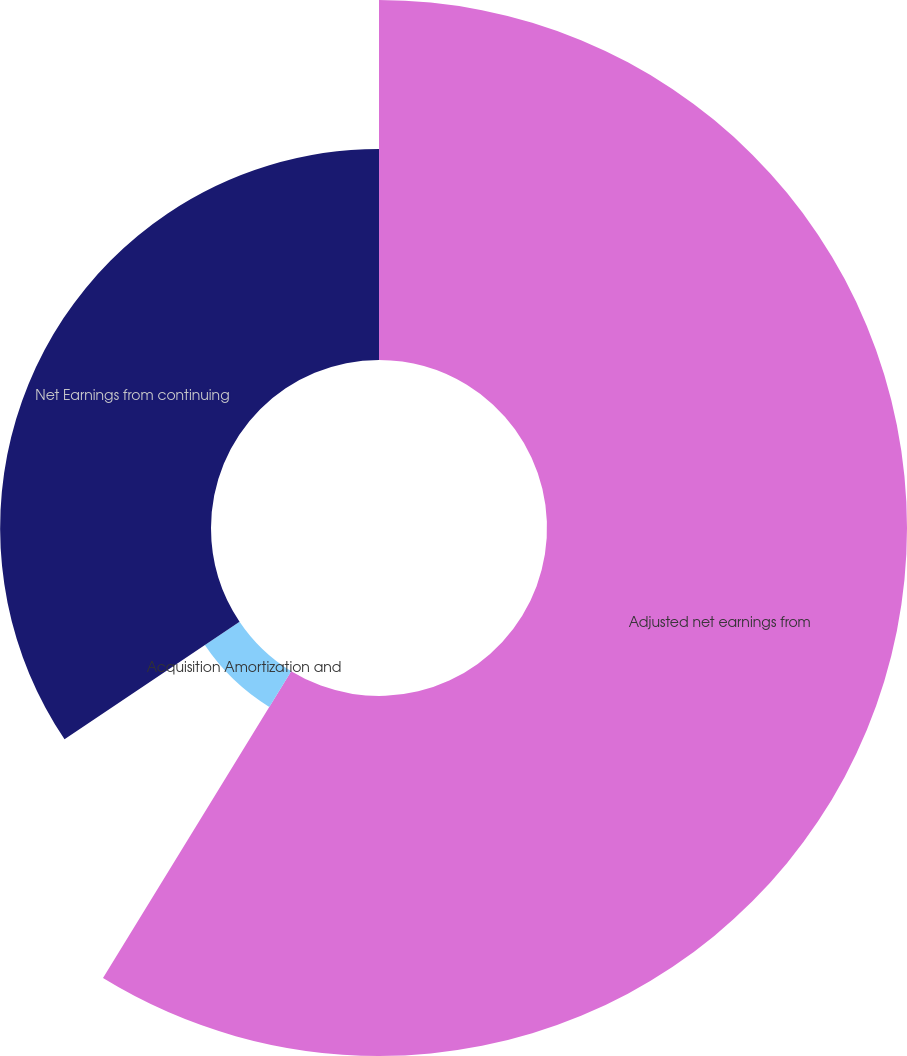Convert chart to OTSL. <chart><loc_0><loc_0><loc_500><loc_500><pie_chart><fcel>Adjusted net earnings from<fcel>Acquisition Amortization and<fcel>Net Earnings from continuing<nl><fcel>58.76%<fcel>6.83%<fcel>34.42%<nl></chart> 